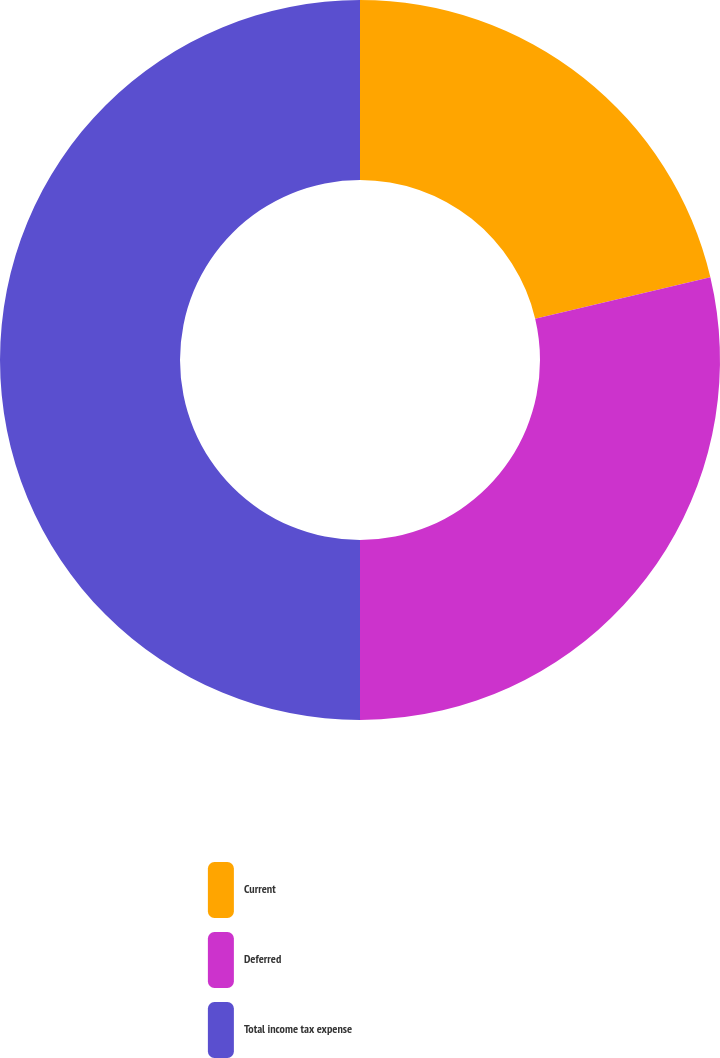Convert chart. <chart><loc_0><loc_0><loc_500><loc_500><pie_chart><fcel>Current<fcel>Deferred<fcel>Total income tax expense<nl><fcel>21.31%<fcel>28.69%<fcel>50.0%<nl></chart> 